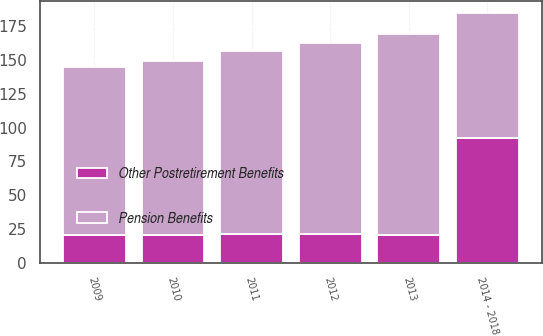Convert chart to OTSL. <chart><loc_0><loc_0><loc_500><loc_500><stacked_bar_chart><ecel><fcel>2009<fcel>2010<fcel>2011<fcel>2012<fcel>2013<fcel>2014 - 2018<nl><fcel>Pension Benefits<fcel>124.6<fcel>128.7<fcel>135.2<fcel>142.2<fcel>148.8<fcel>92.4<nl><fcel>Other Postretirement Benefits<fcel>20.3<fcel>20.6<fcel>21.2<fcel>20.8<fcel>20.3<fcel>92.4<nl></chart> 